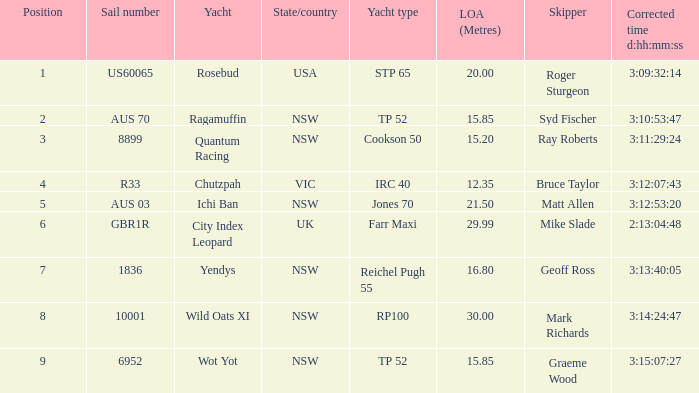What were all Yachts with a sail number of 6952? Wot Yot. Would you mind parsing the complete table? {'header': ['Position', 'Sail number', 'Yacht', 'State/country', 'Yacht type', 'LOA (Metres)', 'Skipper', 'Corrected time d:hh:mm:ss'], 'rows': [['1', 'US60065', 'Rosebud', 'USA', 'STP 65', '20.00', 'Roger Sturgeon', '3:09:32:14'], ['2', 'AUS 70', 'Ragamuffin', 'NSW', 'TP 52', '15.85', 'Syd Fischer', '3:10:53:47'], ['3', '8899', 'Quantum Racing', 'NSW', 'Cookson 50', '15.20', 'Ray Roberts', '3:11:29:24'], ['4', 'R33', 'Chutzpah', 'VIC', 'IRC 40', '12.35', 'Bruce Taylor', '3:12:07:43'], ['5', 'AUS 03', 'Ichi Ban', 'NSW', 'Jones 70', '21.50', 'Matt Allen', '3:12:53:20'], ['6', 'GBR1R', 'City Index Leopard', 'UK', 'Farr Maxi', '29.99', 'Mike Slade', '2:13:04:48'], ['7', '1836', 'Yendys', 'NSW', 'Reichel Pugh 55', '16.80', 'Geoff Ross', '3:13:40:05'], ['8', '10001', 'Wild Oats XI', 'NSW', 'RP100', '30.00', 'Mark Richards', '3:14:24:47'], ['9', '6952', 'Wot Yot', 'NSW', 'TP 52', '15.85', 'Graeme Wood', '3:15:07:27']]} 